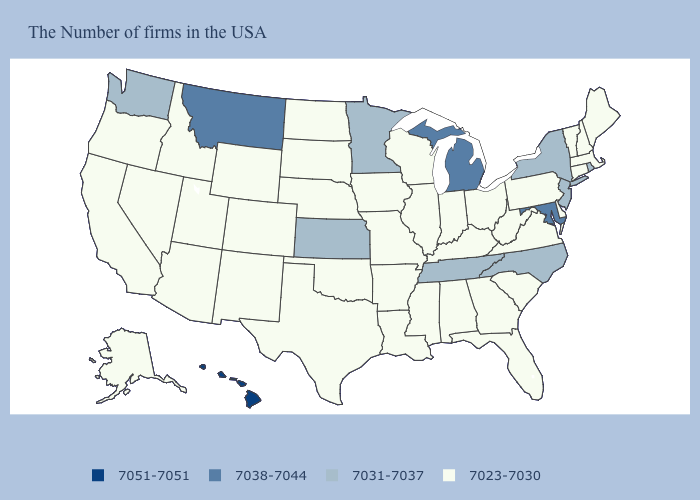Name the states that have a value in the range 7051-7051?
Answer briefly. Hawaii. What is the value of Hawaii?
Concise answer only. 7051-7051. Name the states that have a value in the range 7031-7037?
Keep it brief. Rhode Island, New York, New Jersey, North Carolina, Tennessee, Minnesota, Kansas, Washington. Name the states that have a value in the range 7031-7037?
Short answer required. Rhode Island, New York, New Jersey, North Carolina, Tennessee, Minnesota, Kansas, Washington. What is the highest value in the USA?
Answer briefly. 7051-7051. Name the states that have a value in the range 7031-7037?
Short answer required. Rhode Island, New York, New Jersey, North Carolina, Tennessee, Minnesota, Kansas, Washington. Among the states that border Tennessee , does Arkansas have the highest value?
Be succinct. No. What is the value of Utah?
Be succinct. 7023-7030. Does Washington have the highest value in the USA?
Give a very brief answer. No. What is the value of Tennessee?
Keep it brief. 7031-7037. Name the states that have a value in the range 7038-7044?
Concise answer only. Maryland, Michigan, Montana. What is the value of California?
Write a very short answer. 7023-7030. Name the states that have a value in the range 7051-7051?
Keep it brief. Hawaii. What is the lowest value in the MidWest?
Keep it brief. 7023-7030. 